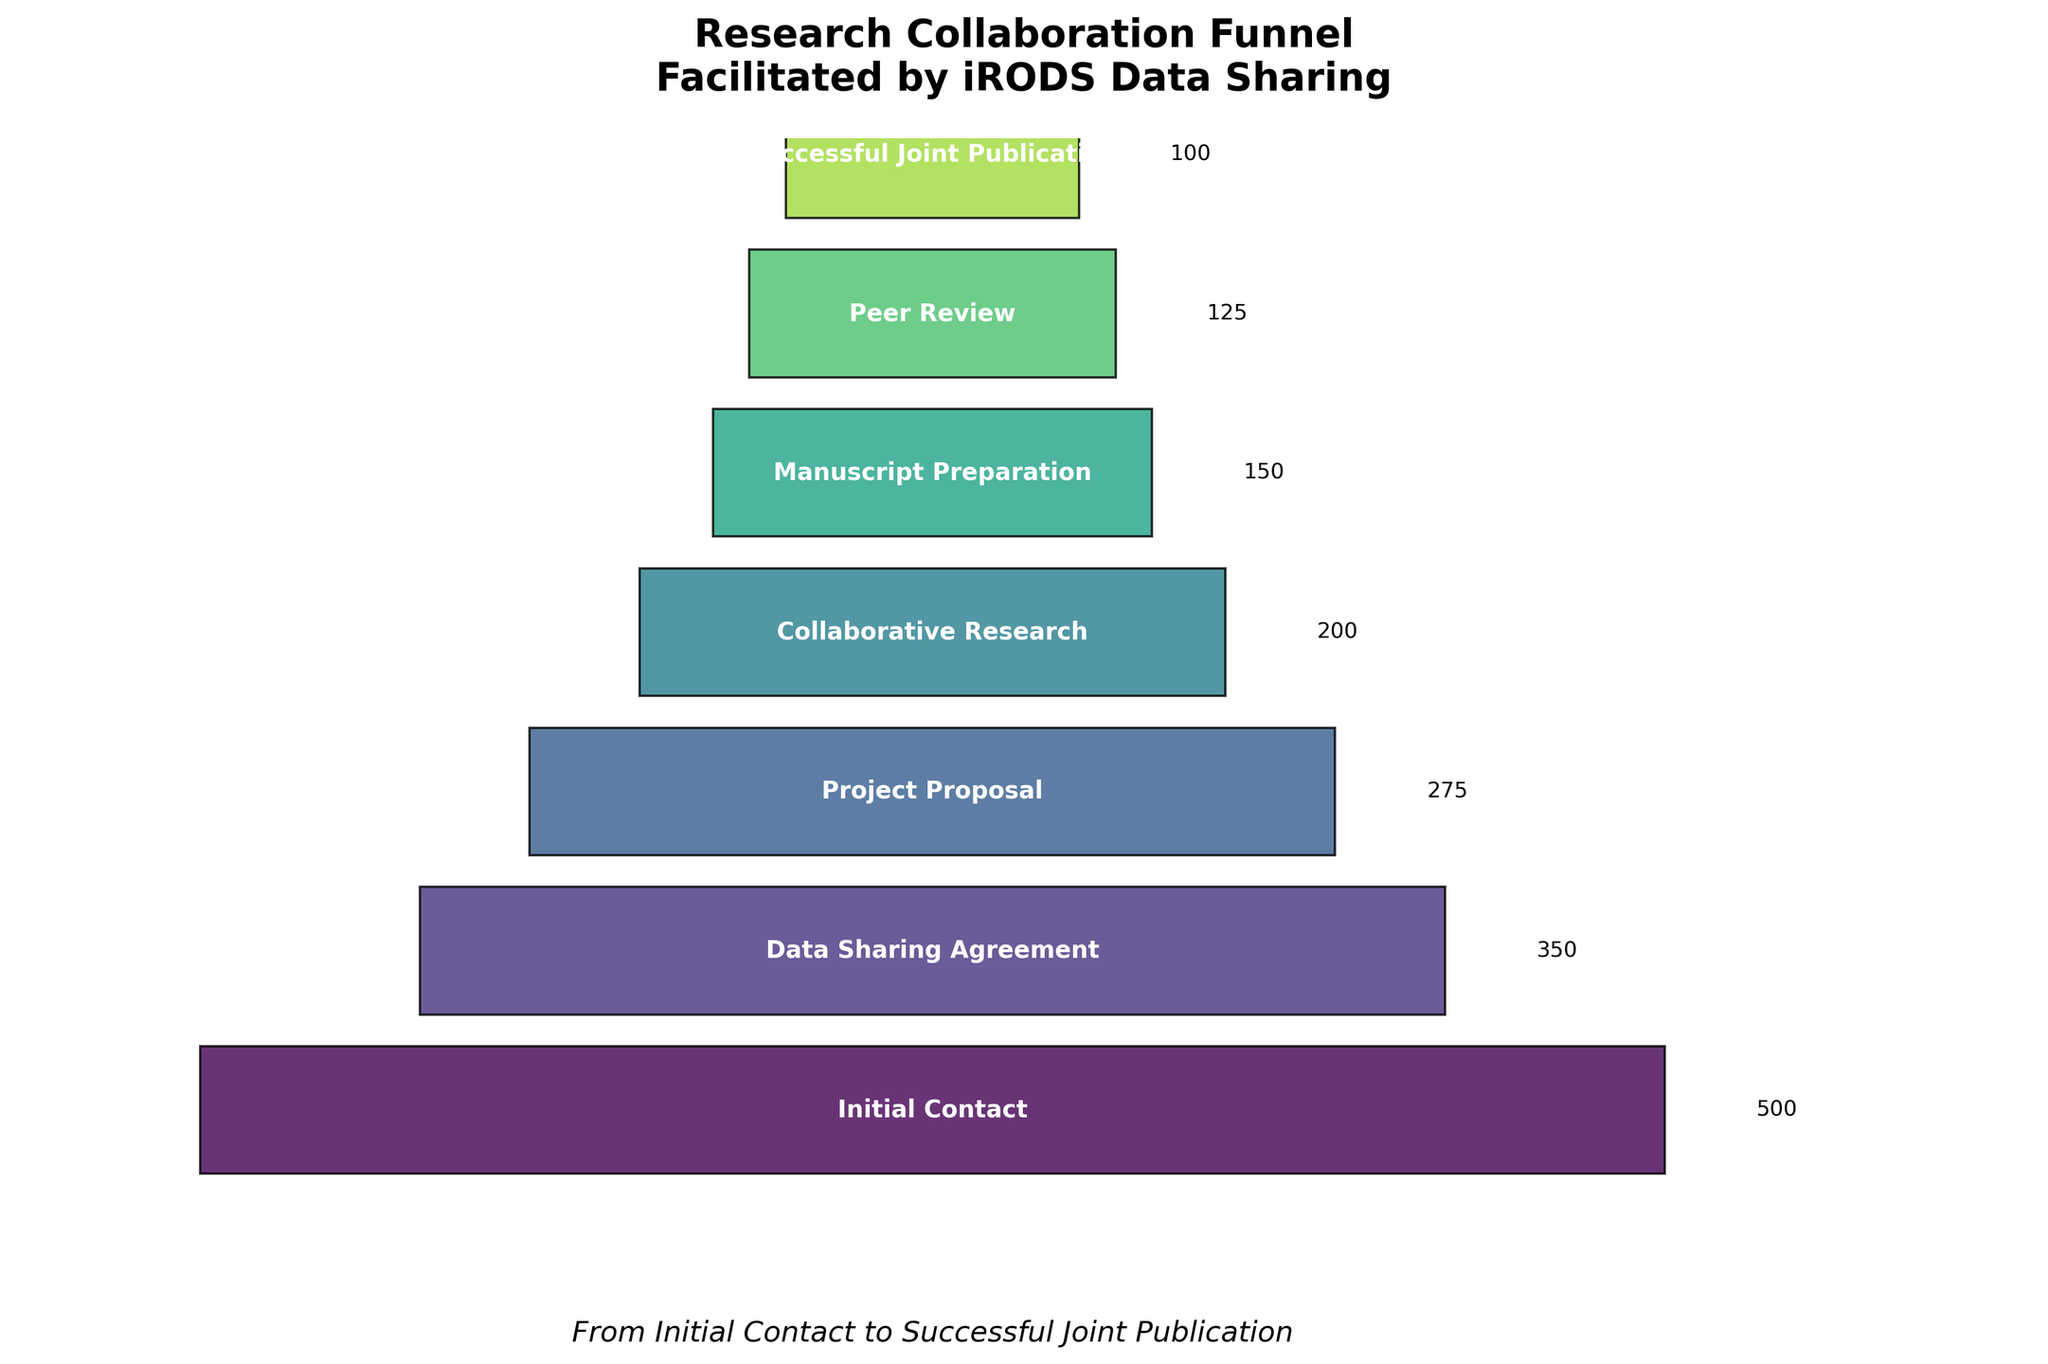What is the title of the figure? The title is usually located at the top of the figure. In this figure, it reads "Research Collaboration Funnel Facilitated by iRODS Data Sharing".
Answer: Research Collaboration Funnel Facilitated by iRODS Data Sharing What is the count at the 'Project Proposal' stage? The count is displayed next to the stage label for 'Project Proposal'. According to the figure, it is 275.
Answer: 275 Which stage has the smallest count? By visually identifying the smallest funnel segment, we can see that the 'Successful Joint Publication' stage has the smallest count.
Answer: Successful Joint Publication How many stages are there in the funnel from initial contact to successful publication? Count the number of distinct stages labeled in the funnel chart: Initial Contact, Data Sharing Agreement, Project Proposal, Collaborative Research, Manuscript Preparation, Peer Review, and Successful Joint Publication. This gives a total of 7 stages.
Answer: 7 What is the total number of contacts that proceed to 'Collaborative Research'? According to the figure, 'Collaborative Research' has 200 participants.
Answer: 200 What percentage of the initial contacts resulted in successful joint publications? To find the percentage, divide the count at the 'Successful Joint Publication' stage by the count at the 'Initial Contact' stage and multiply by 100. So, (100 / 500) * 100 = 20%.
Answer: 20% What is the difference in count between 'Manuscript Preparation' and 'Peer Review' stages? Subtract the count at 'Peer Review' from the count at 'Manuscript Preparation'. According to the figure, 150 (Manuscript Preparation) - 125 (Peer Review) = 25.
Answer: 25 Among 'Data Sharing Agreement', 'Project Proposal', and 'Collaborative Research' stages, which stage has the highest count? Compare the counts at these stages: Data Sharing Agreement (350), Project Proposal (275), and Collaborative Research (200). The highest is 'Data Sharing Agreement'.
Answer: Data Sharing Agreement By what fraction did the count decrease from 'Initial Contact' to 'Data Sharing Agreement'? Subtract the count at 'Data Sharing Agreement' from 'Initial Contact' and divide by 'Initial Contact'. (500 - 350) / 500 = 0.3 or 3/10.
Answer: 3/10 